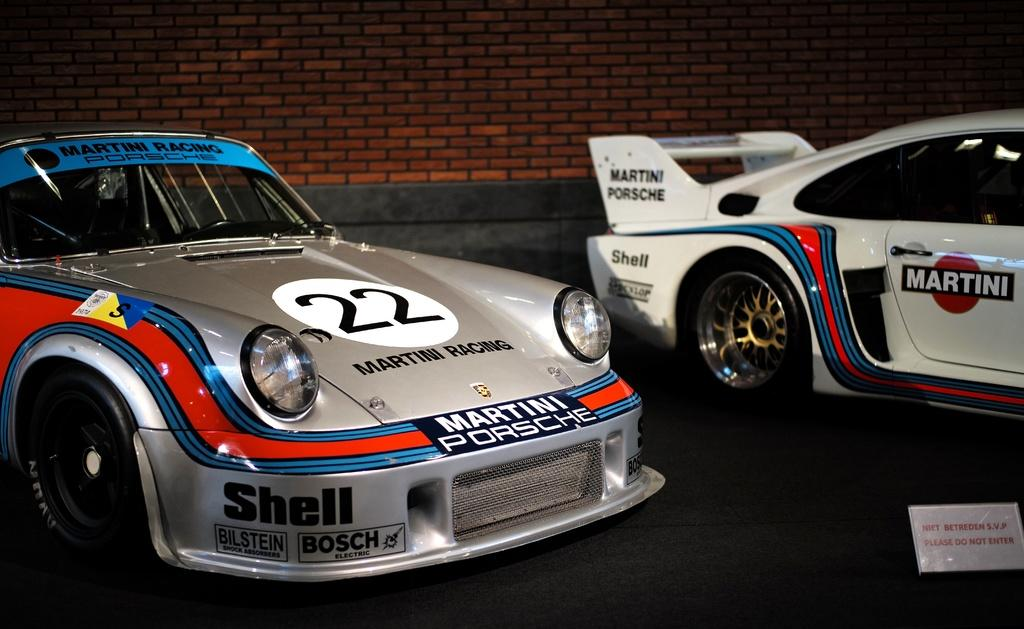How many cars are visible in the image? There are two cars in the image. What else can be seen in the image besides the cars? There is a small board with text and a wall in the image. What word is written on the hot system in the image? There is no hot system or word present in the image. 